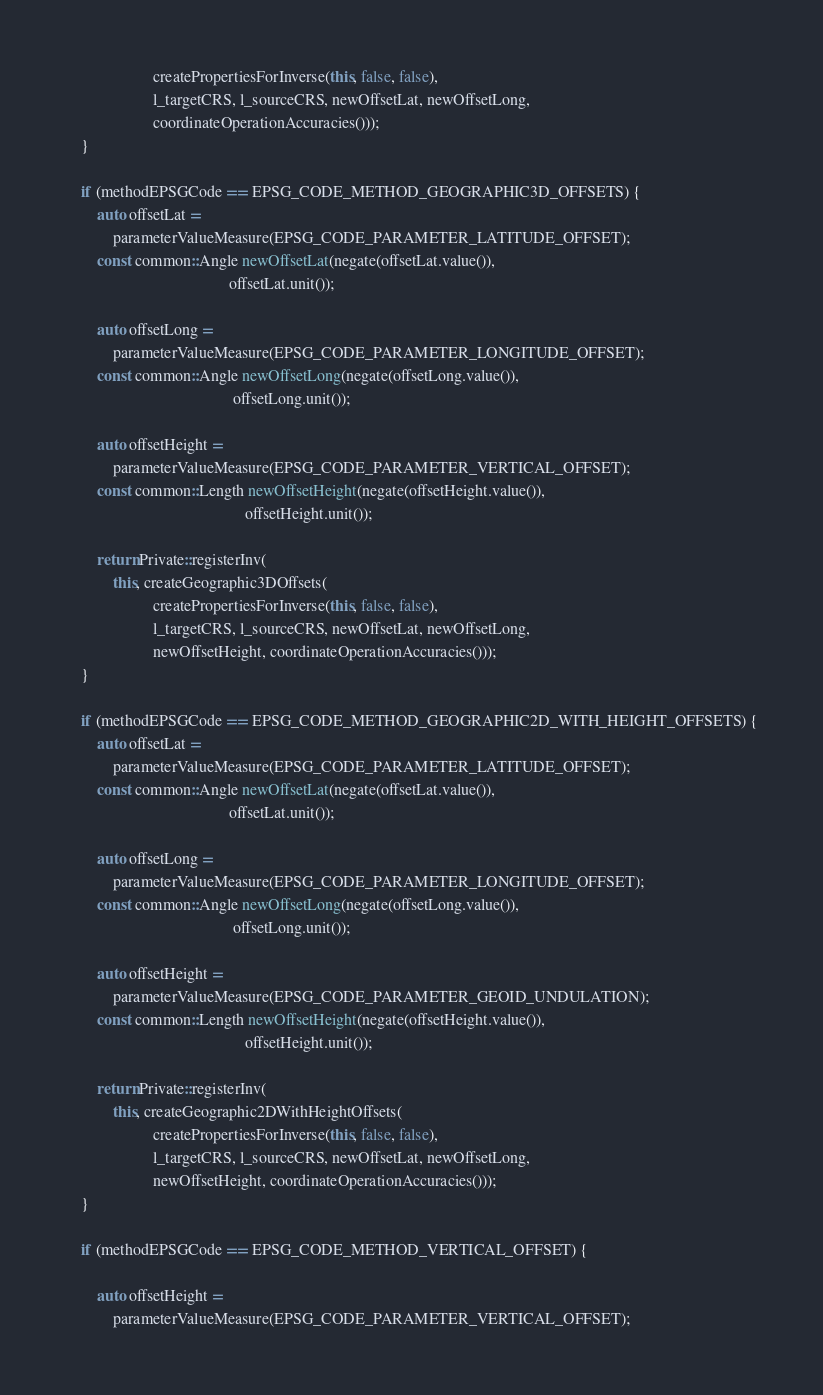<code> <loc_0><loc_0><loc_500><loc_500><_C++_>                      createPropertiesForInverse(this, false, false),
                      l_targetCRS, l_sourceCRS, newOffsetLat, newOffsetLong,
                      coordinateOperationAccuracies()));
    }

    if (methodEPSGCode == EPSG_CODE_METHOD_GEOGRAPHIC3D_OFFSETS) {
        auto offsetLat =
            parameterValueMeasure(EPSG_CODE_PARAMETER_LATITUDE_OFFSET);
        const common::Angle newOffsetLat(negate(offsetLat.value()),
                                         offsetLat.unit());

        auto offsetLong =
            parameterValueMeasure(EPSG_CODE_PARAMETER_LONGITUDE_OFFSET);
        const common::Angle newOffsetLong(negate(offsetLong.value()),
                                          offsetLong.unit());

        auto offsetHeight =
            parameterValueMeasure(EPSG_CODE_PARAMETER_VERTICAL_OFFSET);
        const common::Length newOffsetHeight(negate(offsetHeight.value()),
                                             offsetHeight.unit());

        return Private::registerInv(
            this, createGeographic3DOffsets(
                      createPropertiesForInverse(this, false, false),
                      l_targetCRS, l_sourceCRS, newOffsetLat, newOffsetLong,
                      newOffsetHeight, coordinateOperationAccuracies()));
    }

    if (methodEPSGCode == EPSG_CODE_METHOD_GEOGRAPHIC2D_WITH_HEIGHT_OFFSETS) {
        auto offsetLat =
            parameterValueMeasure(EPSG_CODE_PARAMETER_LATITUDE_OFFSET);
        const common::Angle newOffsetLat(negate(offsetLat.value()),
                                         offsetLat.unit());

        auto offsetLong =
            parameterValueMeasure(EPSG_CODE_PARAMETER_LONGITUDE_OFFSET);
        const common::Angle newOffsetLong(negate(offsetLong.value()),
                                          offsetLong.unit());

        auto offsetHeight =
            parameterValueMeasure(EPSG_CODE_PARAMETER_GEOID_UNDULATION);
        const common::Length newOffsetHeight(negate(offsetHeight.value()),
                                             offsetHeight.unit());

        return Private::registerInv(
            this, createGeographic2DWithHeightOffsets(
                      createPropertiesForInverse(this, false, false),
                      l_targetCRS, l_sourceCRS, newOffsetLat, newOffsetLong,
                      newOffsetHeight, coordinateOperationAccuracies()));
    }

    if (methodEPSGCode == EPSG_CODE_METHOD_VERTICAL_OFFSET) {

        auto offsetHeight =
            parameterValueMeasure(EPSG_CODE_PARAMETER_VERTICAL_OFFSET);</code> 